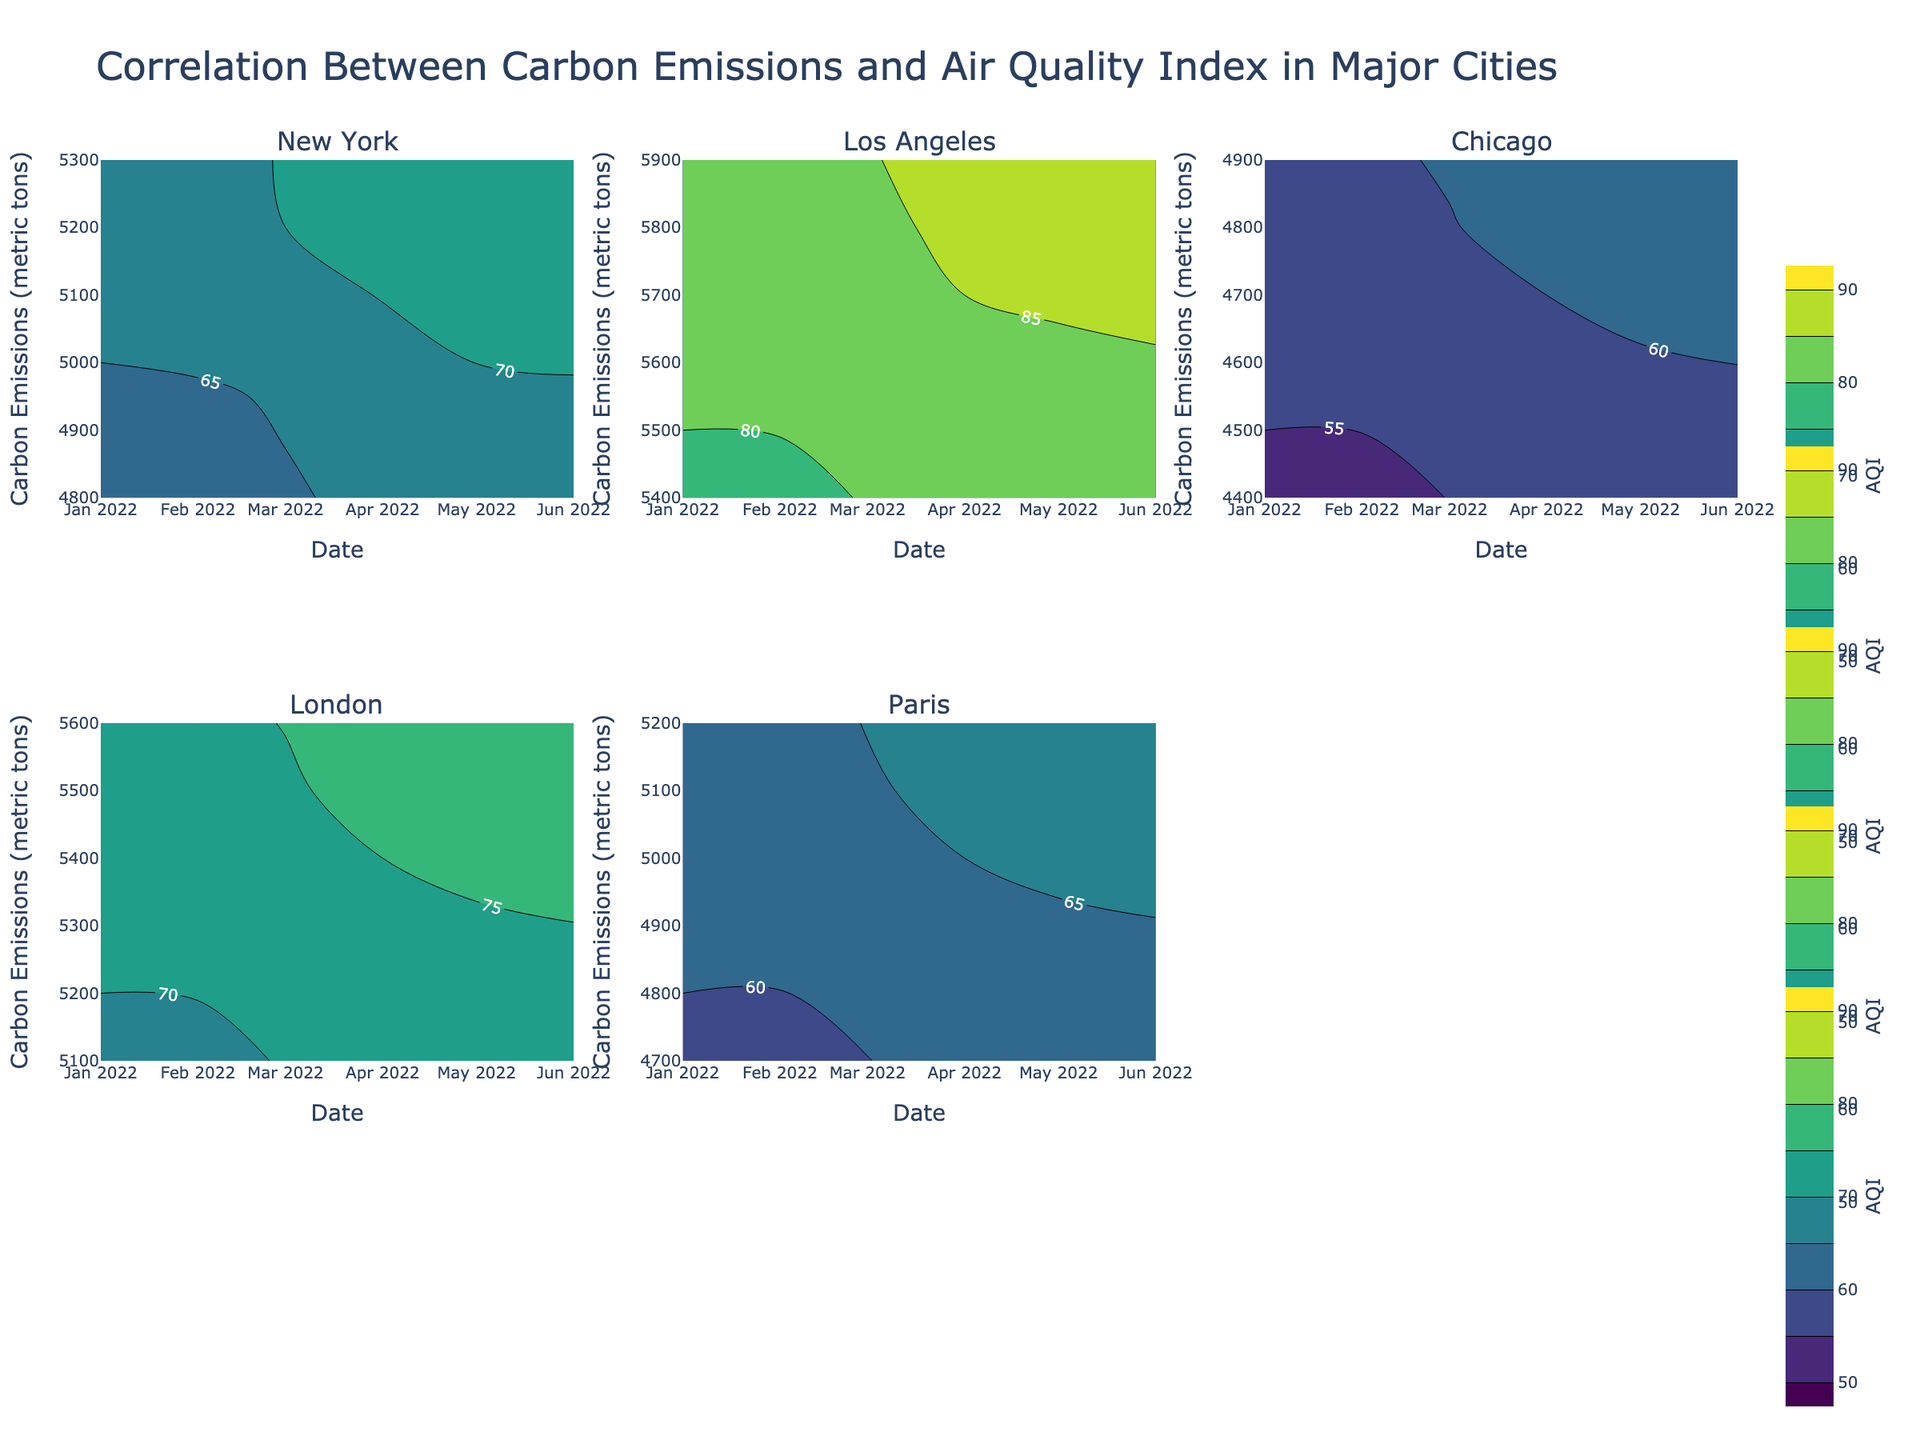How many cities are plotted in the figure? The subplot titles indicate each city. There are six subplot titles corresponding to six different cities: New York, Los Angeles, Chicago, London, and Paris.
Answer: 5 What is the title of the figure? The title is displayed at the top of the figure. It reads: "Correlation Between Carbon Emissions and Air Quality Index in Major Cities".
Answer: Correlation Between Carbon Emissions and Air Quality Index in Major Cities In which city does the Air Quality Index (AQI) reach its highest value? By viewing the contour plots and the AQI color scales, Los Angeles has the highest AQI values, reaching up to 90.
Answer: Los Angeles What is the color scale used in the contour plots? Each subplot uses a "Viridis" color scale, evident from the color gradient spanning from darker to lighter shades.
Answer: Viridis Which city shows a relatively constant trend in Carbon Emissions over time? By inspecting the contour plots, Chicago shows relatively small fluctuations in Carbon Emissions compared to others, indicating a relatively constant trend.
Answer: Chicago Which city's contour plot has Carbon Emissions that peak higher than 5800 metric tons? Observing the y-axis representing Carbon Emissions, both Los Angeles and London have values exceeding 5800 metric tons.
Answer: Los Angeles, London What is the average AQI for Chicago during the first half of 2022? To find the average, identify the AQI values for Chicago from the contour plot and compute the mean of these values: (55 + 52 + 58 + 60 + 63 + 65) / 6 = 58.83
Answer: 58.83 Comparing the average AQI values, is New York's average higher or lower than Paris's average for the same period? Summarize the AQI values for New York (65 + 60 + 70 + 68 + 72 + 75) / 6 = 68.33 and for Paris (60 + 57 + 62 + 65 + 68 + 70) / 6 = 63.67. By comparing the averages, New York's average is higher.
Answer: Higher In which months does London experience an increase in AQI coupled with a rise in Carbon Emissions? Reviewing the contour plot for London shows that from April to June, both AQI and Carbon Emissions generally increase.
Answer: April to June How does the trend in AQI change across the seasons in New York? Observing the contour plot for New York, AQI peaks during warmer months (May to June), and is lower during colder months (January to February).
Answer: Peaks in warmer months, lower in colder months 